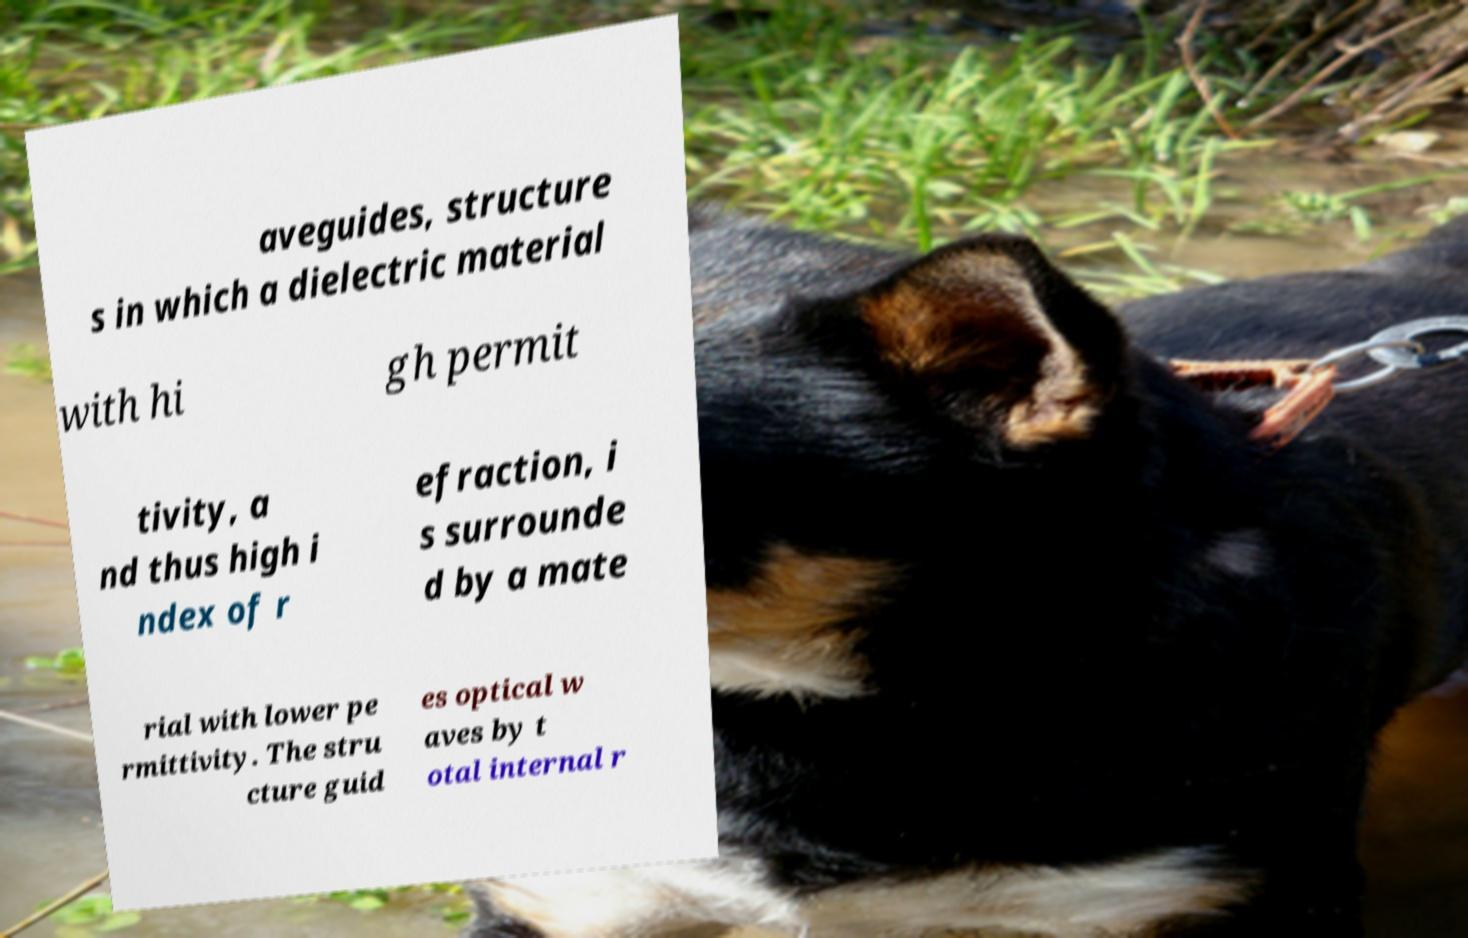Could you extract and type out the text from this image? aveguides, structure s in which a dielectric material with hi gh permit tivity, a nd thus high i ndex of r efraction, i s surrounde d by a mate rial with lower pe rmittivity. The stru cture guid es optical w aves by t otal internal r 